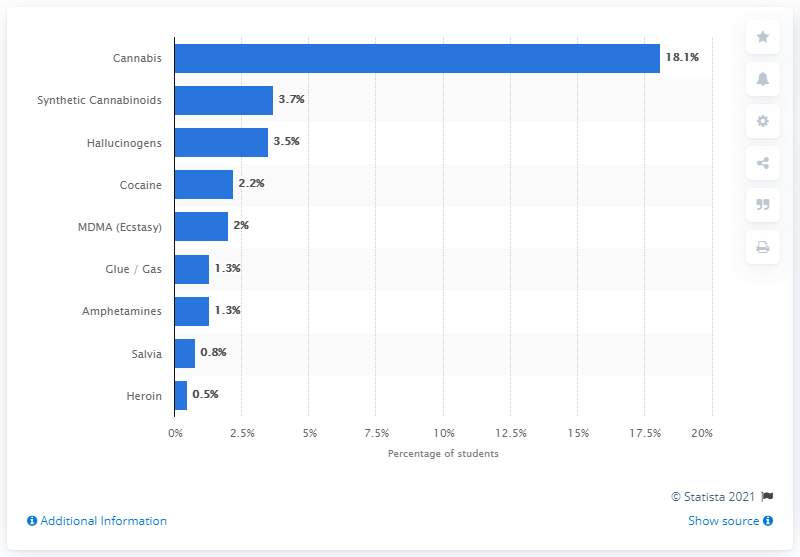Specify some key components in this picture. According to the survey, 2.2% of Canadian students had used cocaine in the past year. 